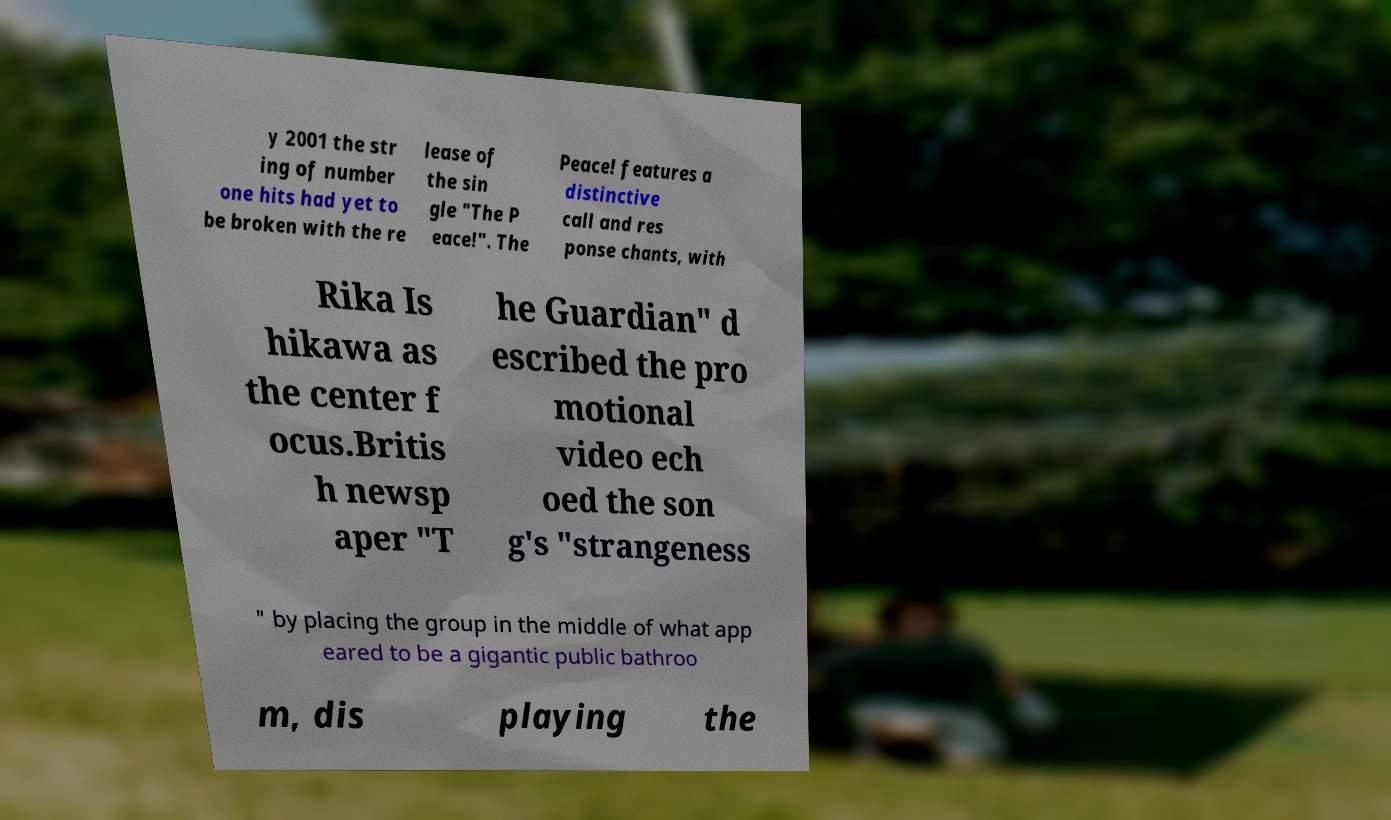What messages or text are displayed in this image? I need them in a readable, typed format. y 2001 the str ing of number one hits had yet to be broken with the re lease of the sin gle "The P eace!". The Peace! features a distinctive call and res ponse chants, with Rika Is hikawa as the center f ocus.Britis h newsp aper "T he Guardian" d escribed the pro motional video ech oed the son g's "strangeness " by placing the group in the middle of what app eared to be a gigantic public bathroo m, dis playing the 